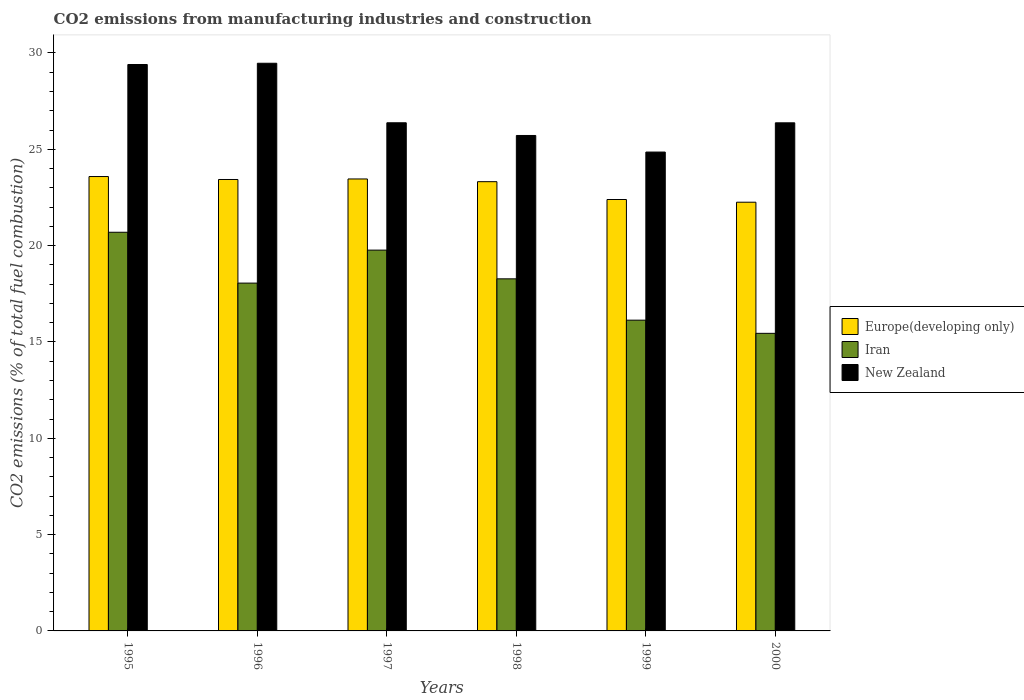Are the number of bars on each tick of the X-axis equal?
Keep it short and to the point. Yes. In how many cases, is the number of bars for a given year not equal to the number of legend labels?
Your response must be concise. 0. What is the amount of CO2 emitted in New Zealand in 1998?
Your answer should be very brief. 25.72. Across all years, what is the maximum amount of CO2 emitted in Iran?
Keep it short and to the point. 20.69. Across all years, what is the minimum amount of CO2 emitted in New Zealand?
Offer a terse response. 24.86. What is the total amount of CO2 emitted in New Zealand in the graph?
Your answer should be very brief. 162.2. What is the difference between the amount of CO2 emitted in Iran in 1995 and that in 1999?
Give a very brief answer. 4.56. What is the difference between the amount of CO2 emitted in Europe(developing only) in 1998 and the amount of CO2 emitted in Iran in 1995?
Make the answer very short. 2.62. What is the average amount of CO2 emitted in New Zealand per year?
Make the answer very short. 27.03. In the year 1996, what is the difference between the amount of CO2 emitted in Europe(developing only) and amount of CO2 emitted in Iran?
Ensure brevity in your answer.  5.38. In how many years, is the amount of CO2 emitted in New Zealand greater than 15 %?
Offer a very short reply. 6. What is the ratio of the amount of CO2 emitted in Europe(developing only) in 1998 to that in 1999?
Your answer should be compact. 1.04. Is the amount of CO2 emitted in Europe(developing only) in 1997 less than that in 1999?
Offer a terse response. No. What is the difference between the highest and the second highest amount of CO2 emitted in Europe(developing only)?
Make the answer very short. 0.13. What is the difference between the highest and the lowest amount of CO2 emitted in New Zealand?
Make the answer very short. 4.61. In how many years, is the amount of CO2 emitted in Europe(developing only) greater than the average amount of CO2 emitted in Europe(developing only) taken over all years?
Your answer should be compact. 4. Is the sum of the amount of CO2 emitted in New Zealand in 1995 and 1998 greater than the maximum amount of CO2 emitted in Europe(developing only) across all years?
Your answer should be compact. Yes. What does the 2nd bar from the left in 2000 represents?
Ensure brevity in your answer.  Iran. What does the 2nd bar from the right in 1996 represents?
Ensure brevity in your answer.  Iran. Is it the case that in every year, the sum of the amount of CO2 emitted in New Zealand and amount of CO2 emitted in Iran is greater than the amount of CO2 emitted in Europe(developing only)?
Provide a succinct answer. Yes. Are all the bars in the graph horizontal?
Make the answer very short. No. How many years are there in the graph?
Provide a succinct answer. 6. What is the difference between two consecutive major ticks on the Y-axis?
Ensure brevity in your answer.  5. Are the values on the major ticks of Y-axis written in scientific E-notation?
Offer a terse response. No. How are the legend labels stacked?
Your response must be concise. Vertical. What is the title of the graph?
Your answer should be compact. CO2 emissions from manufacturing industries and construction. Does "Lithuania" appear as one of the legend labels in the graph?
Offer a very short reply. No. What is the label or title of the Y-axis?
Provide a succinct answer. CO2 emissions (% of total fuel combustion). What is the CO2 emissions (% of total fuel combustion) in Europe(developing only) in 1995?
Keep it short and to the point. 23.59. What is the CO2 emissions (% of total fuel combustion) in Iran in 1995?
Ensure brevity in your answer.  20.69. What is the CO2 emissions (% of total fuel combustion) of New Zealand in 1995?
Provide a short and direct response. 29.4. What is the CO2 emissions (% of total fuel combustion) in Europe(developing only) in 1996?
Offer a very short reply. 23.43. What is the CO2 emissions (% of total fuel combustion) of Iran in 1996?
Make the answer very short. 18.05. What is the CO2 emissions (% of total fuel combustion) of New Zealand in 1996?
Provide a succinct answer. 29.47. What is the CO2 emissions (% of total fuel combustion) in Europe(developing only) in 1997?
Make the answer very short. 23.46. What is the CO2 emissions (% of total fuel combustion) of Iran in 1997?
Your response must be concise. 19.77. What is the CO2 emissions (% of total fuel combustion) of New Zealand in 1997?
Offer a very short reply. 26.38. What is the CO2 emissions (% of total fuel combustion) of Europe(developing only) in 1998?
Your response must be concise. 23.32. What is the CO2 emissions (% of total fuel combustion) of Iran in 1998?
Offer a very short reply. 18.28. What is the CO2 emissions (% of total fuel combustion) in New Zealand in 1998?
Keep it short and to the point. 25.72. What is the CO2 emissions (% of total fuel combustion) in Europe(developing only) in 1999?
Make the answer very short. 22.39. What is the CO2 emissions (% of total fuel combustion) of Iran in 1999?
Offer a very short reply. 16.13. What is the CO2 emissions (% of total fuel combustion) in New Zealand in 1999?
Your answer should be compact. 24.86. What is the CO2 emissions (% of total fuel combustion) of Europe(developing only) in 2000?
Make the answer very short. 22.25. What is the CO2 emissions (% of total fuel combustion) of Iran in 2000?
Offer a terse response. 15.45. What is the CO2 emissions (% of total fuel combustion) of New Zealand in 2000?
Ensure brevity in your answer.  26.38. Across all years, what is the maximum CO2 emissions (% of total fuel combustion) in Europe(developing only)?
Your answer should be very brief. 23.59. Across all years, what is the maximum CO2 emissions (% of total fuel combustion) of Iran?
Your answer should be very brief. 20.69. Across all years, what is the maximum CO2 emissions (% of total fuel combustion) of New Zealand?
Make the answer very short. 29.47. Across all years, what is the minimum CO2 emissions (% of total fuel combustion) in Europe(developing only)?
Give a very brief answer. 22.25. Across all years, what is the minimum CO2 emissions (% of total fuel combustion) of Iran?
Provide a short and direct response. 15.45. Across all years, what is the minimum CO2 emissions (% of total fuel combustion) in New Zealand?
Offer a terse response. 24.86. What is the total CO2 emissions (% of total fuel combustion) in Europe(developing only) in the graph?
Offer a terse response. 138.45. What is the total CO2 emissions (% of total fuel combustion) in Iran in the graph?
Ensure brevity in your answer.  108.37. What is the total CO2 emissions (% of total fuel combustion) of New Zealand in the graph?
Offer a very short reply. 162.2. What is the difference between the CO2 emissions (% of total fuel combustion) of Europe(developing only) in 1995 and that in 1996?
Provide a short and direct response. 0.15. What is the difference between the CO2 emissions (% of total fuel combustion) in Iran in 1995 and that in 1996?
Provide a succinct answer. 2.64. What is the difference between the CO2 emissions (% of total fuel combustion) in New Zealand in 1995 and that in 1996?
Offer a terse response. -0.06. What is the difference between the CO2 emissions (% of total fuel combustion) in Europe(developing only) in 1995 and that in 1997?
Keep it short and to the point. 0.13. What is the difference between the CO2 emissions (% of total fuel combustion) in Iran in 1995 and that in 1997?
Provide a succinct answer. 0.93. What is the difference between the CO2 emissions (% of total fuel combustion) of New Zealand in 1995 and that in 1997?
Your response must be concise. 3.02. What is the difference between the CO2 emissions (% of total fuel combustion) of Europe(developing only) in 1995 and that in 1998?
Ensure brevity in your answer.  0.27. What is the difference between the CO2 emissions (% of total fuel combustion) of Iran in 1995 and that in 1998?
Offer a terse response. 2.42. What is the difference between the CO2 emissions (% of total fuel combustion) of New Zealand in 1995 and that in 1998?
Your answer should be compact. 3.68. What is the difference between the CO2 emissions (% of total fuel combustion) in Europe(developing only) in 1995 and that in 1999?
Keep it short and to the point. 1.19. What is the difference between the CO2 emissions (% of total fuel combustion) in Iran in 1995 and that in 1999?
Make the answer very short. 4.56. What is the difference between the CO2 emissions (% of total fuel combustion) of New Zealand in 1995 and that in 1999?
Provide a short and direct response. 4.54. What is the difference between the CO2 emissions (% of total fuel combustion) in Europe(developing only) in 1995 and that in 2000?
Your answer should be compact. 1.33. What is the difference between the CO2 emissions (% of total fuel combustion) of Iran in 1995 and that in 2000?
Your answer should be compact. 5.25. What is the difference between the CO2 emissions (% of total fuel combustion) in New Zealand in 1995 and that in 2000?
Provide a short and direct response. 3.03. What is the difference between the CO2 emissions (% of total fuel combustion) of Europe(developing only) in 1996 and that in 1997?
Your answer should be very brief. -0.03. What is the difference between the CO2 emissions (% of total fuel combustion) in Iran in 1996 and that in 1997?
Provide a succinct answer. -1.71. What is the difference between the CO2 emissions (% of total fuel combustion) of New Zealand in 1996 and that in 1997?
Keep it short and to the point. 3.09. What is the difference between the CO2 emissions (% of total fuel combustion) in Europe(developing only) in 1996 and that in 1998?
Offer a very short reply. 0.11. What is the difference between the CO2 emissions (% of total fuel combustion) in Iran in 1996 and that in 1998?
Your response must be concise. -0.22. What is the difference between the CO2 emissions (% of total fuel combustion) of New Zealand in 1996 and that in 1998?
Offer a terse response. 3.75. What is the difference between the CO2 emissions (% of total fuel combustion) in Europe(developing only) in 1996 and that in 1999?
Offer a very short reply. 1.04. What is the difference between the CO2 emissions (% of total fuel combustion) in Iran in 1996 and that in 1999?
Your response must be concise. 1.92. What is the difference between the CO2 emissions (% of total fuel combustion) of New Zealand in 1996 and that in 1999?
Give a very brief answer. 4.61. What is the difference between the CO2 emissions (% of total fuel combustion) of Europe(developing only) in 1996 and that in 2000?
Make the answer very short. 1.18. What is the difference between the CO2 emissions (% of total fuel combustion) of Iran in 1996 and that in 2000?
Offer a very short reply. 2.61. What is the difference between the CO2 emissions (% of total fuel combustion) of New Zealand in 1996 and that in 2000?
Give a very brief answer. 3.09. What is the difference between the CO2 emissions (% of total fuel combustion) of Europe(developing only) in 1997 and that in 1998?
Keep it short and to the point. 0.14. What is the difference between the CO2 emissions (% of total fuel combustion) in Iran in 1997 and that in 1998?
Make the answer very short. 1.49. What is the difference between the CO2 emissions (% of total fuel combustion) of New Zealand in 1997 and that in 1998?
Give a very brief answer. 0.66. What is the difference between the CO2 emissions (% of total fuel combustion) in Europe(developing only) in 1997 and that in 1999?
Your answer should be very brief. 1.07. What is the difference between the CO2 emissions (% of total fuel combustion) in Iran in 1997 and that in 1999?
Provide a short and direct response. 3.64. What is the difference between the CO2 emissions (% of total fuel combustion) of New Zealand in 1997 and that in 1999?
Your answer should be compact. 1.52. What is the difference between the CO2 emissions (% of total fuel combustion) in Europe(developing only) in 1997 and that in 2000?
Your response must be concise. 1.21. What is the difference between the CO2 emissions (% of total fuel combustion) in Iran in 1997 and that in 2000?
Offer a terse response. 4.32. What is the difference between the CO2 emissions (% of total fuel combustion) of New Zealand in 1997 and that in 2000?
Keep it short and to the point. 0. What is the difference between the CO2 emissions (% of total fuel combustion) of Europe(developing only) in 1998 and that in 1999?
Keep it short and to the point. 0.93. What is the difference between the CO2 emissions (% of total fuel combustion) in Iran in 1998 and that in 1999?
Make the answer very short. 2.14. What is the difference between the CO2 emissions (% of total fuel combustion) of New Zealand in 1998 and that in 1999?
Your answer should be very brief. 0.86. What is the difference between the CO2 emissions (% of total fuel combustion) of Europe(developing only) in 1998 and that in 2000?
Provide a short and direct response. 1.07. What is the difference between the CO2 emissions (% of total fuel combustion) in Iran in 1998 and that in 2000?
Give a very brief answer. 2.83. What is the difference between the CO2 emissions (% of total fuel combustion) of New Zealand in 1998 and that in 2000?
Provide a succinct answer. -0.66. What is the difference between the CO2 emissions (% of total fuel combustion) of Europe(developing only) in 1999 and that in 2000?
Give a very brief answer. 0.14. What is the difference between the CO2 emissions (% of total fuel combustion) of Iran in 1999 and that in 2000?
Ensure brevity in your answer.  0.68. What is the difference between the CO2 emissions (% of total fuel combustion) of New Zealand in 1999 and that in 2000?
Your answer should be compact. -1.52. What is the difference between the CO2 emissions (% of total fuel combustion) of Europe(developing only) in 1995 and the CO2 emissions (% of total fuel combustion) of Iran in 1996?
Give a very brief answer. 5.53. What is the difference between the CO2 emissions (% of total fuel combustion) in Europe(developing only) in 1995 and the CO2 emissions (% of total fuel combustion) in New Zealand in 1996?
Provide a short and direct response. -5.88. What is the difference between the CO2 emissions (% of total fuel combustion) in Iran in 1995 and the CO2 emissions (% of total fuel combustion) in New Zealand in 1996?
Your answer should be very brief. -8.77. What is the difference between the CO2 emissions (% of total fuel combustion) in Europe(developing only) in 1995 and the CO2 emissions (% of total fuel combustion) in Iran in 1997?
Your answer should be very brief. 3.82. What is the difference between the CO2 emissions (% of total fuel combustion) of Europe(developing only) in 1995 and the CO2 emissions (% of total fuel combustion) of New Zealand in 1997?
Keep it short and to the point. -2.79. What is the difference between the CO2 emissions (% of total fuel combustion) of Iran in 1995 and the CO2 emissions (% of total fuel combustion) of New Zealand in 1997?
Make the answer very short. -5.68. What is the difference between the CO2 emissions (% of total fuel combustion) of Europe(developing only) in 1995 and the CO2 emissions (% of total fuel combustion) of Iran in 1998?
Offer a terse response. 5.31. What is the difference between the CO2 emissions (% of total fuel combustion) in Europe(developing only) in 1995 and the CO2 emissions (% of total fuel combustion) in New Zealand in 1998?
Make the answer very short. -2.13. What is the difference between the CO2 emissions (% of total fuel combustion) in Iran in 1995 and the CO2 emissions (% of total fuel combustion) in New Zealand in 1998?
Give a very brief answer. -5.02. What is the difference between the CO2 emissions (% of total fuel combustion) of Europe(developing only) in 1995 and the CO2 emissions (% of total fuel combustion) of Iran in 1999?
Make the answer very short. 7.46. What is the difference between the CO2 emissions (% of total fuel combustion) in Europe(developing only) in 1995 and the CO2 emissions (% of total fuel combustion) in New Zealand in 1999?
Provide a short and direct response. -1.27. What is the difference between the CO2 emissions (% of total fuel combustion) in Iran in 1995 and the CO2 emissions (% of total fuel combustion) in New Zealand in 1999?
Provide a short and direct response. -4.16. What is the difference between the CO2 emissions (% of total fuel combustion) in Europe(developing only) in 1995 and the CO2 emissions (% of total fuel combustion) in Iran in 2000?
Your answer should be very brief. 8.14. What is the difference between the CO2 emissions (% of total fuel combustion) of Europe(developing only) in 1995 and the CO2 emissions (% of total fuel combustion) of New Zealand in 2000?
Your response must be concise. -2.79. What is the difference between the CO2 emissions (% of total fuel combustion) in Iran in 1995 and the CO2 emissions (% of total fuel combustion) in New Zealand in 2000?
Give a very brief answer. -5.68. What is the difference between the CO2 emissions (% of total fuel combustion) of Europe(developing only) in 1996 and the CO2 emissions (% of total fuel combustion) of Iran in 1997?
Make the answer very short. 3.67. What is the difference between the CO2 emissions (% of total fuel combustion) in Europe(developing only) in 1996 and the CO2 emissions (% of total fuel combustion) in New Zealand in 1997?
Your answer should be compact. -2.94. What is the difference between the CO2 emissions (% of total fuel combustion) in Iran in 1996 and the CO2 emissions (% of total fuel combustion) in New Zealand in 1997?
Keep it short and to the point. -8.32. What is the difference between the CO2 emissions (% of total fuel combustion) of Europe(developing only) in 1996 and the CO2 emissions (% of total fuel combustion) of Iran in 1998?
Provide a succinct answer. 5.16. What is the difference between the CO2 emissions (% of total fuel combustion) of Europe(developing only) in 1996 and the CO2 emissions (% of total fuel combustion) of New Zealand in 1998?
Your answer should be very brief. -2.29. What is the difference between the CO2 emissions (% of total fuel combustion) of Iran in 1996 and the CO2 emissions (% of total fuel combustion) of New Zealand in 1998?
Make the answer very short. -7.66. What is the difference between the CO2 emissions (% of total fuel combustion) of Europe(developing only) in 1996 and the CO2 emissions (% of total fuel combustion) of Iran in 1999?
Ensure brevity in your answer.  7.3. What is the difference between the CO2 emissions (% of total fuel combustion) of Europe(developing only) in 1996 and the CO2 emissions (% of total fuel combustion) of New Zealand in 1999?
Offer a terse response. -1.42. What is the difference between the CO2 emissions (% of total fuel combustion) of Iran in 1996 and the CO2 emissions (% of total fuel combustion) of New Zealand in 1999?
Give a very brief answer. -6.8. What is the difference between the CO2 emissions (% of total fuel combustion) of Europe(developing only) in 1996 and the CO2 emissions (% of total fuel combustion) of Iran in 2000?
Ensure brevity in your answer.  7.99. What is the difference between the CO2 emissions (% of total fuel combustion) of Europe(developing only) in 1996 and the CO2 emissions (% of total fuel combustion) of New Zealand in 2000?
Your answer should be very brief. -2.94. What is the difference between the CO2 emissions (% of total fuel combustion) in Iran in 1996 and the CO2 emissions (% of total fuel combustion) in New Zealand in 2000?
Ensure brevity in your answer.  -8.32. What is the difference between the CO2 emissions (% of total fuel combustion) in Europe(developing only) in 1997 and the CO2 emissions (% of total fuel combustion) in Iran in 1998?
Your answer should be very brief. 5.18. What is the difference between the CO2 emissions (% of total fuel combustion) in Europe(developing only) in 1997 and the CO2 emissions (% of total fuel combustion) in New Zealand in 1998?
Ensure brevity in your answer.  -2.26. What is the difference between the CO2 emissions (% of total fuel combustion) in Iran in 1997 and the CO2 emissions (% of total fuel combustion) in New Zealand in 1998?
Offer a very short reply. -5.95. What is the difference between the CO2 emissions (% of total fuel combustion) in Europe(developing only) in 1997 and the CO2 emissions (% of total fuel combustion) in Iran in 1999?
Offer a terse response. 7.33. What is the difference between the CO2 emissions (% of total fuel combustion) in Europe(developing only) in 1997 and the CO2 emissions (% of total fuel combustion) in New Zealand in 1999?
Make the answer very short. -1.4. What is the difference between the CO2 emissions (% of total fuel combustion) in Iran in 1997 and the CO2 emissions (% of total fuel combustion) in New Zealand in 1999?
Provide a short and direct response. -5.09. What is the difference between the CO2 emissions (% of total fuel combustion) of Europe(developing only) in 1997 and the CO2 emissions (% of total fuel combustion) of Iran in 2000?
Ensure brevity in your answer.  8.01. What is the difference between the CO2 emissions (% of total fuel combustion) of Europe(developing only) in 1997 and the CO2 emissions (% of total fuel combustion) of New Zealand in 2000?
Offer a very short reply. -2.91. What is the difference between the CO2 emissions (% of total fuel combustion) of Iran in 1997 and the CO2 emissions (% of total fuel combustion) of New Zealand in 2000?
Give a very brief answer. -6.61. What is the difference between the CO2 emissions (% of total fuel combustion) in Europe(developing only) in 1998 and the CO2 emissions (% of total fuel combustion) in Iran in 1999?
Your answer should be compact. 7.19. What is the difference between the CO2 emissions (% of total fuel combustion) of Europe(developing only) in 1998 and the CO2 emissions (% of total fuel combustion) of New Zealand in 1999?
Provide a short and direct response. -1.54. What is the difference between the CO2 emissions (% of total fuel combustion) of Iran in 1998 and the CO2 emissions (% of total fuel combustion) of New Zealand in 1999?
Keep it short and to the point. -6.58. What is the difference between the CO2 emissions (% of total fuel combustion) in Europe(developing only) in 1998 and the CO2 emissions (% of total fuel combustion) in Iran in 2000?
Keep it short and to the point. 7.87. What is the difference between the CO2 emissions (% of total fuel combustion) of Europe(developing only) in 1998 and the CO2 emissions (% of total fuel combustion) of New Zealand in 2000?
Your response must be concise. -3.06. What is the difference between the CO2 emissions (% of total fuel combustion) in Iran in 1998 and the CO2 emissions (% of total fuel combustion) in New Zealand in 2000?
Give a very brief answer. -8.1. What is the difference between the CO2 emissions (% of total fuel combustion) of Europe(developing only) in 1999 and the CO2 emissions (% of total fuel combustion) of Iran in 2000?
Offer a terse response. 6.95. What is the difference between the CO2 emissions (% of total fuel combustion) in Europe(developing only) in 1999 and the CO2 emissions (% of total fuel combustion) in New Zealand in 2000?
Provide a succinct answer. -3.98. What is the difference between the CO2 emissions (% of total fuel combustion) of Iran in 1999 and the CO2 emissions (% of total fuel combustion) of New Zealand in 2000?
Keep it short and to the point. -10.24. What is the average CO2 emissions (% of total fuel combustion) of Europe(developing only) per year?
Your response must be concise. 23.07. What is the average CO2 emissions (% of total fuel combustion) of Iran per year?
Ensure brevity in your answer.  18.06. What is the average CO2 emissions (% of total fuel combustion) in New Zealand per year?
Provide a short and direct response. 27.03. In the year 1995, what is the difference between the CO2 emissions (% of total fuel combustion) in Europe(developing only) and CO2 emissions (% of total fuel combustion) in Iran?
Make the answer very short. 2.89. In the year 1995, what is the difference between the CO2 emissions (% of total fuel combustion) of Europe(developing only) and CO2 emissions (% of total fuel combustion) of New Zealand?
Your answer should be very brief. -5.82. In the year 1995, what is the difference between the CO2 emissions (% of total fuel combustion) in Iran and CO2 emissions (% of total fuel combustion) in New Zealand?
Provide a succinct answer. -8.71. In the year 1996, what is the difference between the CO2 emissions (% of total fuel combustion) in Europe(developing only) and CO2 emissions (% of total fuel combustion) in Iran?
Keep it short and to the point. 5.38. In the year 1996, what is the difference between the CO2 emissions (% of total fuel combustion) in Europe(developing only) and CO2 emissions (% of total fuel combustion) in New Zealand?
Offer a terse response. -6.03. In the year 1996, what is the difference between the CO2 emissions (% of total fuel combustion) in Iran and CO2 emissions (% of total fuel combustion) in New Zealand?
Make the answer very short. -11.41. In the year 1997, what is the difference between the CO2 emissions (% of total fuel combustion) in Europe(developing only) and CO2 emissions (% of total fuel combustion) in Iran?
Provide a short and direct response. 3.69. In the year 1997, what is the difference between the CO2 emissions (% of total fuel combustion) in Europe(developing only) and CO2 emissions (% of total fuel combustion) in New Zealand?
Offer a terse response. -2.92. In the year 1997, what is the difference between the CO2 emissions (% of total fuel combustion) of Iran and CO2 emissions (% of total fuel combustion) of New Zealand?
Your answer should be very brief. -6.61. In the year 1998, what is the difference between the CO2 emissions (% of total fuel combustion) in Europe(developing only) and CO2 emissions (% of total fuel combustion) in Iran?
Provide a short and direct response. 5.04. In the year 1998, what is the difference between the CO2 emissions (% of total fuel combustion) in Europe(developing only) and CO2 emissions (% of total fuel combustion) in New Zealand?
Offer a very short reply. -2.4. In the year 1998, what is the difference between the CO2 emissions (% of total fuel combustion) of Iran and CO2 emissions (% of total fuel combustion) of New Zealand?
Ensure brevity in your answer.  -7.44. In the year 1999, what is the difference between the CO2 emissions (% of total fuel combustion) in Europe(developing only) and CO2 emissions (% of total fuel combustion) in Iran?
Your response must be concise. 6.26. In the year 1999, what is the difference between the CO2 emissions (% of total fuel combustion) of Europe(developing only) and CO2 emissions (% of total fuel combustion) of New Zealand?
Keep it short and to the point. -2.46. In the year 1999, what is the difference between the CO2 emissions (% of total fuel combustion) in Iran and CO2 emissions (% of total fuel combustion) in New Zealand?
Keep it short and to the point. -8.73. In the year 2000, what is the difference between the CO2 emissions (% of total fuel combustion) in Europe(developing only) and CO2 emissions (% of total fuel combustion) in Iran?
Offer a terse response. 6.81. In the year 2000, what is the difference between the CO2 emissions (% of total fuel combustion) of Europe(developing only) and CO2 emissions (% of total fuel combustion) of New Zealand?
Offer a very short reply. -4.12. In the year 2000, what is the difference between the CO2 emissions (% of total fuel combustion) of Iran and CO2 emissions (% of total fuel combustion) of New Zealand?
Make the answer very short. -10.93. What is the ratio of the CO2 emissions (% of total fuel combustion) in Europe(developing only) in 1995 to that in 1996?
Your answer should be very brief. 1.01. What is the ratio of the CO2 emissions (% of total fuel combustion) in Iran in 1995 to that in 1996?
Make the answer very short. 1.15. What is the ratio of the CO2 emissions (% of total fuel combustion) of New Zealand in 1995 to that in 1996?
Provide a short and direct response. 1. What is the ratio of the CO2 emissions (% of total fuel combustion) of Europe(developing only) in 1995 to that in 1997?
Your response must be concise. 1.01. What is the ratio of the CO2 emissions (% of total fuel combustion) in Iran in 1995 to that in 1997?
Give a very brief answer. 1.05. What is the ratio of the CO2 emissions (% of total fuel combustion) in New Zealand in 1995 to that in 1997?
Ensure brevity in your answer.  1.11. What is the ratio of the CO2 emissions (% of total fuel combustion) of Europe(developing only) in 1995 to that in 1998?
Ensure brevity in your answer.  1.01. What is the ratio of the CO2 emissions (% of total fuel combustion) of Iran in 1995 to that in 1998?
Offer a very short reply. 1.13. What is the ratio of the CO2 emissions (% of total fuel combustion) in New Zealand in 1995 to that in 1998?
Offer a terse response. 1.14. What is the ratio of the CO2 emissions (% of total fuel combustion) of Europe(developing only) in 1995 to that in 1999?
Provide a short and direct response. 1.05. What is the ratio of the CO2 emissions (% of total fuel combustion) of Iran in 1995 to that in 1999?
Provide a succinct answer. 1.28. What is the ratio of the CO2 emissions (% of total fuel combustion) in New Zealand in 1995 to that in 1999?
Offer a very short reply. 1.18. What is the ratio of the CO2 emissions (% of total fuel combustion) in Europe(developing only) in 1995 to that in 2000?
Provide a short and direct response. 1.06. What is the ratio of the CO2 emissions (% of total fuel combustion) of Iran in 1995 to that in 2000?
Your answer should be very brief. 1.34. What is the ratio of the CO2 emissions (% of total fuel combustion) in New Zealand in 1995 to that in 2000?
Your answer should be compact. 1.11. What is the ratio of the CO2 emissions (% of total fuel combustion) in Europe(developing only) in 1996 to that in 1997?
Your response must be concise. 1. What is the ratio of the CO2 emissions (% of total fuel combustion) in Iran in 1996 to that in 1997?
Your response must be concise. 0.91. What is the ratio of the CO2 emissions (% of total fuel combustion) in New Zealand in 1996 to that in 1997?
Your response must be concise. 1.12. What is the ratio of the CO2 emissions (% of total fuel combustion) in Europe(developing only) in 1996 to that in 1998?
Offer a terse response. 1. What is the ratio of the CO2 emissions (% of total fuel combustion) of Iran in 1996 to that in 1998?
Make the answer very short. 0.99. What is the ratio of the CO2 emissions (% of total fuel combustion) in New Zealand in 1996 to that in 1998?
Give a very brief answer. 1.15. What is the ratio of the CO2 emissions (% of total fuel combustion) of Europe(developing only) in 1996 to that in 1999?
Offer a very short reply. 1.05. What is the ratio of the CO2 emissions (% of total fuel combustion) of Iran in 1996 to that in 1999?
Keep it short and to the point. 1.12. What is the ratio of the CO2 emissions (% of total fuel combustion) of New Zealand in 1996 to that in 1999?
Your response must be concise. 1.19. What is the ratio of the CO2 emissions (% of total fuel combustion) of Europe(developing only) in 1996 to that in 2000?
Offer a terse response. 1.05. What is the ratio of the CO2 emissions (% of total fuel combustion) in Iran in 1996 to that in 2000?
Offer a very short reply. 1.17. What is the ratio of the CO2 emissions (% of total fuel combustion) of New Zealand in 1996 to that in 2000?
Your response must be concise. 1.12. What is the ratio of the CO2 emissions (% of total fuel combustion) of Europe(developing only) in 1997 to that in 1998?
Your answer should be compact. 1.01. What is the ratio of the CO2 emissions (% of total fuel combustion) in Iran in 1997 to that in 1998?
Provide a succinct answer. 1.08. What is the ratio of the CO2 emissions (% of total fuel combustion) in New Zealand in 1997 to that in 1998?
Provide a short and direct response. 1.03. What is the ratio of the CO2 emissions (% of total fuel combustion) in Europe(developing only) in 1997 to that in 1999?
Provide a short and direct response. 1.05. What is the ratio of the CO2 emissions (% of total fuel combustion) of Iran in 1997 to that in 1999?
Your answer should be very brief. 1.23. What is the ratio of the CO2 emissions (% of total fuel combustion) of New Zealand in 1997 to that in 1999?
Offer a terse response. 1.06. What is the ratio of the CO2 emissions (% of total fuel combustion) of Europe(developing only) in 1997 to that in 2000?
Ensure brevity in your answer.  1.05. What is the ratio of the CO2 emissions (% of total fuel combustion) of Iran in 1997 to that in 2000?
Provide a succinct answer. 1.28. What is the ratio of the CO2 emissions (% of total fuel combustion) of New Zealand in 1997 to that in 2000?
Provide a succinct answer. 1. What is the ratio of the CO2 emissions (% of total fuel combustion) in Europe(developing only) in 1998 to that in 1999?
Your answer should be very brief. 1.04. What is the ratio of the CO2 emissions (% of total fuel combustion) of Iran in 1998 to that in 1999?
Your answer should be compact. 1.13. What is the ratio of the CO2 emissions (% of total fuel combustion) in New Zealand in 1998 to that in 1999?
Provide a short and direct response. 1.03. What is the ratio of the CO2 emissions (% of total fuel combustion) in Europe(developing only) in 1998 to that in 2000?
Your response must be concise. 1.05. What is the ratio of the CO2 emissions (% of total fuel combustion) in Iran in 1998 to that in 2000?
Offer a very short reply. 1.18. What is the ratio of the CO2 emissions (% of total fuel combustion) of New Zealand in 1998 to that in 2000?
Provide a succinct answer. 0.98. What is the ratio of the CO2 emissions (% of total fuel combustion) of Europe(developing only) in 1999 to that in 2000?
Make the answer very short. 1.01. What is the ratio of the CO2 emissions (% of total fuel combustion) in Iran in 1999 to that in 2000?
Your answer should be compact. 1.04. What is the ratio of the CO2 emissions (% of total fuel combustion) of New Zealand in 1999 to that in 2000?
Offer a terse response. 0.94. What is the difference between the highest and the second highest CO2 emissions (% of total fuel combustion) of Europe(developing only)?
Offer a very short reply. 0.13. What is the difference between the highest and the second highest CO2 emissions (% of total fuel combustion) of Iran?
Give a very brief answer. 0.93. What is the difference between the highest and the second highest CO2 emissions (% of total fuel combustion) of New Zealand?
Offer a very short reply. 0.06. What is the difference between the highest and the lowest CO2 emissions (% of total fuel combustion) in Europe(developing only)?
Offer a terse response. 1.33. What is the difference between the highest and the lowest CO2 emissions (% of total fuel combustion) of Iran?
Make the answer very short. 5.25. What is the difference between the highest and the lowest CO2 emissions (% of total fuel combustion) in New Zealand?
Give a very brief answer. 4.61. 